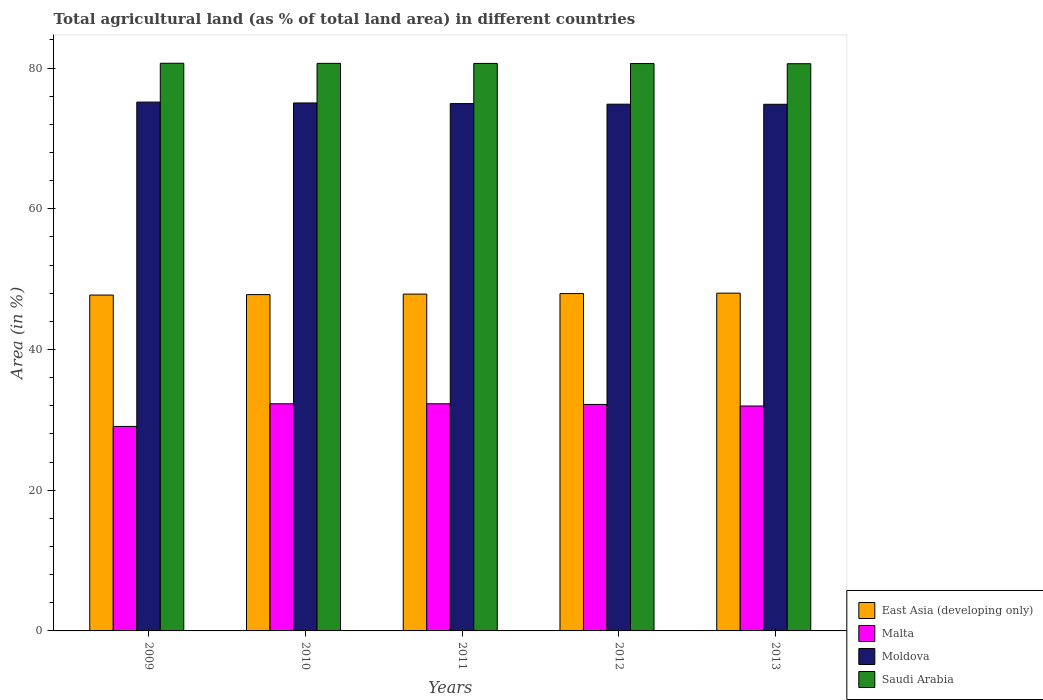How many groups of bars are there?
Provide a succinct answer. 5. What is the label of the 5th group of bars from the left?
Ensure brevity in your answer.  2013. What is the percentage of agricultural land in Malta in 2009?
Give a very brief answer. 29.06. Across all years, what is the maximum percentage of agricultural land in Malta?
Make the answer very short. 32.28. Across all years, what is the minimum percentage of agricultural land in Saudi Arabia?
Give a very brief answer. 80.61. What is the total percentage of agricultural land in Malta in the graph?
Provide a succinct answer. 157.78. What is the difference between the percentage of agricultural land in East Asia (developing only) in 2011 and that in 2013?
Give a very brief answer. -0.13. What is the difference between the percentage of agricultural land in East Asia (developing only) in 2010 and the percentage of agricultural land in Malta in 2013?
Your answer should be compact. 15.83. What is the average percentage of agricultural land in Malta per year?
Your response must be concise. 31.56. In the year 2013, what is the difference between the percentage of agricultural land in Saudi Arabia and percentage of agricultural land in Moldova?
Keep it short and to the point. 5.77. What is the ratio of the percentage of agricultural land in Saudi Arabia in 2009 to that in 2010?
Your response must be concise. 1. Is the percentage of agricultural land in Moldova in 2010 less than that in 2011?
Provide a succinct answer. No. Is the difference between the percentage of agricultural land in Saudi Arabia in 2010 and 2012 greater than the difference between the percentage of agricultural land in Moldova in 2010 and 2012?
Your response must be concise. No. What is the difference between the highest and the second highest percentage of agricultural land in Saudi Arabia?
Make the answer very short. 0.01. What is the difference between the highest and the lowest percentage of agricultural land in Saudi Arabia?
Offer a terse response. 0.07. Is the sum of the percentage of agricultural land in Malta in 2010 and 2012 greater than the maximum percentage of agricultural land in East Asia (developing only) across all years?
Provide a succinct answer. Yes. What does the 3rd bar from the left in 2009 represents?
Your answer should be very brief. Moldova. What does the 1st bar from the right in 2011 represents?
Offer a terse response. Saudi Arabia. Are all the bars in the graph horizontal?
Your response must be concise. No. How many years are there in the graph?
Give a very brief answer. 5. What is the difference between two consecutive major ticks on the Y-axis?
Ensure brevity in your answer.  20. Are the values on the major ticks of Y-axis written in scientific E-notation?
Your response must be concise. No. How many legend labels are there?
Keep it short and to the point. 4. How are the legend labels stacked?
Provide a short and direct response. Vertical. What is the title of the graph?
Your answer should be compact. Total agricultural land (as % of total land area) in different countries. What is the label or title of the Y-axis?
Keep it short and to the point. Area (in %). What is the Area (in %) of East Asia (developing only) in 2009?
Offer a terse response. 47.74. What is the Area (in %) in Malta in 2009?
Offer a very short reply. 29.06. What is the Area (in %) of Moldova in 2009?
Your answer should be very brief. 75.16. What is the Area (in %) of Saudi Arabia in 2009?
Give a very brief answer. 80.68. What is the Area (in %) of East Asia (developing only) in 2010?
Your response must be concise. 47.8. What is the Area (in %) in Malta in 2010?
Ensure brevity in your answer.  32.28. What is the Area (in %) of Moldova in 2010?
Make the answer very short. 75.04. What is the Area (in %) of Saudi Arabia in 2010?
Give a very brief answer. 80.67. What is the Area (in %) of East Asia (developing only) in 2011?
Your response must be concise. 47.87. What is the Area (in %) in Malta in 2011?
Provide a succinct answer. 32.28. What is the Area (in %) in Moldova in 2011?
Ensure brevity in your answer.  74.95. What is the Area (in %) in Saudi Arabia in 2011?
Offer a terse response. 80.66. What is the Area (in %) in East Asia (developing only) in 2012?
Ensure brevity in your answer.  47.95. What is the Area (in %) in Malta in 2012?
Give a very brief answer. 32.19. What is the Area (in %) in Moldova in 2012?
Ensure brevity in your answer.  74.86. What is the Area (in %) of Saudi Arabia in 2012?
Give a very brief answer. 80.64. What is the Area (in %) in East Asia (developing only) in 2013?
Ensure brevity in your answer.  48. What is the Area (in %) in Malta in 2013?
Offer a terse response. 31.97. What is the Area (in %) of Moldova in 2013?
Offer a very short reply. 74.85. What is the Area (in %) of Saudi Arabia in 2013?
Your answer should be compact. 80.61. Across all years, what is the maximum Area (in %) of East Asia (developing only)?
Your answer should be very brief. 48. Across all years, what is the maximum Area (in %) in Malta?
Your answer should be compact. 32.28. Across all years, what is the maximum Area (in %) of Moldova?
Offer a terse response. 75.16. Across all years, what is the maximum Area (in %) of Saudi Arabia?
Offer a very short reply. 80.68. Across all years, what is the minimum Area (in %) of East Asia (developing only)?
Ensure brevity in your answer.  47.74. Across all years, what is the minimum Area (in %) of Malta?
Your response must be concise. 29.06. Across all years, what is the minimum Area (in %) in Moldova?
Make the answer very short. 74.85. Across all years, what is the minimum Area (in %) of Saudi Arabia?
Provide a short and direct response. 80.61. What is the total Area (in %) in East Asia (developing only) in the graph?
Your answer should be compact. 239.35. What is the total Area (in %) of Malta in the graph?
Give a very brief answer. 157.78. What is the total Area (in %) of Moldova in the graph?
Give a very brief answer. 374.86. What is the total Area (in %) of Saudi Arabia in the graph?
Ensure brevity in your answer.  403.25. What is the difference between the Area (in %) in East Asia (developing only) in 2009 and that in 2010?
Offer a very short reply. -0.06. What is the difference between the Area (in %) of Malta in 2009 and that in 2010?
Give a very brief answer. -3.22. What is the difference between the Area (in %) in Moldova in 2009 and that in 2010?
Provide a succinct answer. 0.12. What is the difference between the Area (in %) in Saudi Arabia in 2009 and that in 2010?
Your answer should be compact. 0.01. What is the difference between the Area (in %) in East Asia (developing only) in 2009 and that in 2011?
Your answer should be compact. -0.14. What is the difference between the Area (in %) in Malta in 2009 and that in 2011?
Keep it short and to the point. -3.22. What is the difference between the Area (in %) of Moldova in 2009 and that in 2011?
Your answer should be compact. 0.21. What is the difference between the Area (in %) of Saudi Arabia in 2009 and that in 2011?
Your answer should be compact. 0.02. What is the difference between the Area (in %) in East Asia (developing only) in 2009 and that in 2012?
Offer a very short reply. -0.21. What is the difference between the Area (in %) of Malta in 2009 and that in 2012?
Your answer should be compact. -3.12. What is the difference between the Area (in %) of Moldova in 2009 and that in 2012?
Keep it short and to the point. 0.3. What is the difference between the Area (in %) in Saudi Arabia in 2009 and that in 2012?
Your answer should be very brief. 0.04. What is the difference between the Area (in %) in East Asia (developing only) in 2009 and that in 2013?
Your answer should be compact. -0.27. What is the difference between the Area (in %) in Malta in 2009 and that in 2013?
Your answer should be very brief. -2.91. What is the difference between the Area (in %) of Moldova in 2009 and that in 2013?
Your answer should be compact. 0.31. What is the difference between the Area (in %) in Saudi Arabia in 2009 and that in 2013?
Provide a succinct answer. 0.07. What is the difference between the Area (in %) in East Asia (developing only) in 2010 and that in 2011?
Ensure brevity in your answer.  -0.08. What is the difference between the Area (in %) of Malta in 2010 and that in 2011?
Offer a very short reply. 0. What is the difference between the Area (in %) of Moldova in 2010 and that in 2011?
Your answer should be compact. 0.09. What is the difference between the Area (in %) in Saudi Arabia in 2010 and that in 2011?
Make the answer very short. 0.01. What is the difference between the Area (in %) of East Asia (developing only) in 2010 and that in 2012?
Provide a succinct answer. -0.15. What is the difference between the Area (in %) in Malta in 2010 and that in 2012?
Your response must be concise. 0.09. What is the difference between the Area (in %) in Moldova in 2010 and that in 2012?
Offer a very short reply. 0.17. What is the difference between the Area (in %) of Saudi Arabia in 2010 and that in 2012?
Give a very brief answer. 0.03. What is the difference between the Area (in %) in East Asia (developing only) in 2010 and that in 2013?
Your response must be concise. -0.21. What is the difference between the Area (in %) of Malta in 2010 and that in 2013?
Your response must be concise. 0.31. What is the difference between the Area (in %) of Moldova in 2010 and that in 2013?
Offer a very short reply. 0.19. What is the difference between the Area (in %) of Saudi Arabia in 2010 and that in 2013?
Offer a very short reply. 0.05. What is the difference between the Area (in %) in East Asia (developing only) in 2011 and that in 2012?
Make the answer very short. -0.07. What is the difference between the Area (in %) in Malta in 2011 and that in 2012?
Your answer should be very brief. 0.09. What is the difference between the Area (in %) in Moldova in 2011 and that in 2012?
Provide a succinct answer. 0.08. What is the difference between the Area (in %) in Saudi Arabia in 2011 and that in 2012?
Provide a short and direct response. 0.02. What is the difference between the Area (in %) in East Asia (developing only) in 2011 and that in 2013?
Provide a succinct answer. -0.13. What is the difference between the Area (in %) of Malta in 2011 and that in 2013?
Your response must be concise. 0.31. What is the difference between the Area (in %) in Moldova in 2011 and that in 2013?
Give a very brief answer. 0.1. What is the difference between the Area (in %) in Saudi Arabia in 2011 and that in 2013?
Ensure brevity in your answer.  0.04. What is the difference between the Area (in %) of East Asia (developing only) in 2012 and that in 2013?
Give a very brief answer. -0.06. What is the difference between the Area (in %) of Malta in 2012 and that in 2013?
Keep it short and to the point. 0.22. What is the difference between the Area (in %) of Moldova in 2012 and that in 2013?
Offer a terse response. 0.02. What is the difference between the Area (in %) of Saudi Arabia in 2012 and that in 2013?
Provide a succinct answer. 0.02. What is the difference between the Area (in %) of East Asia (developing only) in 2009 and the Area (in %) of Malta in 2010?
Keep it short and to the point. 15.45. What is the difference between the Area (in %) in East Asia (developing only) in 2009 and the Area (in %) in Moldova in 2010?
Your answer should be compact. -27.3. What is the difference between the Area (in %) in East Asia (developing only) in 2009 and the Area (in %) in Saudi Arabia in 2010?
Keep it short and to the point. -32.93. What is the difference between the Area (in %) in Malta in 2009 and the Area (in %) in Moldova in 2010?
Ensure brevity in your answer.  -45.98. What is the difference between the Area (in %) in Malta in 2009 and the Area (in %) in Saudi Arabia in 2010?
Provide a short and direct response. -51.6. What is the difference between the Area (in %) of Moldova in 2009 and the Area (in %) of Saudi Arabia in 2010?
Ensure brevity in your answer.  -5.51. What is the difference between the Area (in %) in East Asia (developing only) in 2009 and the Area (in %) in Malta in 2011?
Provide a succinct answer. 15.45. What is the difference between the Area (in %) in East Asia (developing only) in 2009 and the Area (in %) in Moldova in 2011?
Provide a short and direct response. -27.21. What is the difference between the Area (in %) in East Asia (developing only) in 2009 and the Area (in %) in Saudi Arabia in 2011?
Give a very brief answer. -32.92. What is the difference between the Area (in %) of Malta in 2009 and the Area (in %) of Moldova in 2011?
Offer a terse response. -45.88. What is the difference between the Area (in %) of Malta in 2009 and the Area (in %) of Saudi Arabia in 2011?
Provide a short and direct response. -51.59. What is the difference between the Area (in %) of Moldova in 2009 and the Area (in %) of Saudi Arabia in 2011?
Keep it short and to the point. -5.5. What is the difference between the Area (in %) of East Asia (developing only) in 2009 and the Area (in %) of Malta in 2012?
Provide a succinct answer. 15.55. What is the difference between the Area (in %) of East Asia (developing only) in 2009 and the Area (in %) of Moldova in 2012?
Your answer should be very brief. -27.13. What is the difference between the Area (in %) of East Asia (developing only) in 2009 and the Area (in %) of Saudi Arabia in 2012?
Ensure brevity in your answer.  -32.9. What is the difference between the Area (in %) in Malta in 2009 and the Area (in %) in Moldova in 2012?
Make the answer very short. -45.8. What is the difference between the Area (in %) in Malta in 2009 and the Area (in %) in Saudi Arabia in 2012?
Offer a terse response. -51.57. What is the difference between the Area (in %) of Moldova in 2009 and the Area (in %) of Saudi Arabia in 2012?
Keep it short and to the point. -5.48. What is the difference between the Area (in %) in East Asia (developing only) in 2009 and the Area (in %) in Malta in 2013?
Give a very brief answer. 15.77. What is the difference between the Area (in %) in East Asia (developing only) in 2009 and the Area (in %) in Moldova in 2013?
Offer a terse response. -27.11. What is the difference between the Area (in %) of East Asia (developing only) in 2009 and the Area (in %) of Saudi Arabia in 2013?
Provide a succinct answer. -32.88. What is the difference between the Area (in %) in Malta in 2009 and the Area (in %) in Moldova in 2013?
Your answer should be very brief. -45.79. What is the difference between the Area (in %) of Malta in 2009 and the Area (in %) of Saudi Arabia in 2013?
Provide a short and direct response. -51.55. What is the difference between the Area (in %) in Moldova in 2009 and the Area (in %) in Saudi Arabia in 2013?
Your answer should be very brief. -5.45. What is the difference between the Area (in %) in East Asia (developing only) in 2010 and the Area (in %) in Malta in 2011?
Give a very brief answer. 15.52. What is the difference between the Area (in %) in East Asia (developing only) in 2010 and the Area (in %) in Moldova in 2011?
Make the answer very short. -27.15. What is the difference between the Area (in %) in East Asia (developing only) in 2010 and the Area (in %) in Saudi Arabia in 2011?
Offer a very short reply. -32.86. What is the difference between the Area (in %) of Malta in 2010 and the Area (in %) of Moldova in 2011?
Provide a succinct answer. -42.67. What is the difference between the Area (in %) in Malta in 2010 and the Area (in %) in Saudi Arabia in 2011?
Make the answer very short. -48.38. What is the difference between the Area (in %) of Moldova in 2010 and the Area (in %) of Saudi Arabia in 2011?
Offer a terse response. -5.62. What is the difference between the Area (in %) in East Asia (developing only) in 2010 and the Area (in %) in Malta in 2012?
Make the answer very short. 15.61. What is the difference between the Area (in %) of East Asia (developing only) in 2010 and the Area (in %) of Moldova in 2012?
Your answer should be compact. -27.07. What is the difference between the Area (in %) of East Asia (developing only) in 2010 and the Area (in %) of Saudi Arabia in 2012?
Your response must be concise. -32.84. What is the difference between the Area (in %) of Malta in 2010 and the Area (in %) of Moldova in 2012?
Make the answer very short. -42.58. What is the difference between the Area (in %) in Malta in 2010 and the Area (in %) in Saudi Arabia in 2012?
Keep it short and to the point. -48.36. What is the difference between the Area (in %) of Moldova in 2010 and the Area (in %) of Saudi Arabia in 2012?
Give a very brief answer. -5.6. What is the difference between the Area (in %) in East Asia (developing only) in 2010 and the Area (in %) in Malta in 2013?
Your answer should be very brief. 15.83. What is the difference between the Area (in %) of East Asia (developing only) in 2010 and the Area (in %) of Moldova in 2013?
Your answer should be compact. -27.05. What is the difference between the Area (in %) in East Asia (developing only) in 2010 and the Area (in %) in Saudi Arabia in 2013?
Give a very brief answer. -32.82. What is the difference between the Area (in %) in Malta in 2010 and the Area (in %) in Moldova in 2013?
Provide a succinct answer. -42.57. What is the difference between the Area (in %) in Malta in 2010 and the Area (in %) in Saudi Arabia in 2013?
Offer a very short reply. -48.33. What is the difference between the Area (in %) in Moldova in 2010 and the Area (in %) in Saudi Arabia in 2013?
Keep it short and to the point. -5.58. What is the difference between the Area (in %) in East Asia (developing only) in 2011 and the Area (in %) in Malta in 2012?
Offer a terse response. 15.68. What is the difference between the Area (in %) in East Asia (developing only) in 2011 and the Area (in %) in Moldova in 2012?
Ensure brevity in your answer.  -26.99. What is the difference between the Area (in %) of East Asia (developing only) in 2011 and the Area (in %) of Saudi Arabia in 2012?
Give a very brief answer. -32.77. What is the difference between the Area (in %) of Malta in 2011 and the Area (in %) of Moldova in 2012?
Provide a short and direct response. -42.58. What is the difference between the Area (in %) of Malta in 2011 and the Area (in %) of Saudi Arabia in 2012?
Ensure brevity in your answer.  -48.36. What is the difference between the Area (in %) of Moldova in 2011 and the Area (in %) of Saudi Arabia in 2012?
Give a very brief answer. -5.69. What is the difference between the Area (in %) of East Asia (developing only) in 2011 and the Area (in %) of Malta in 2013?
Your response must be concise. 15.9. What is the difference between the Area (in %) in East Asia (developing only) in 2011 and the Area (in %) in Moldova in 2013?
Your response must be concise. -26.98. What is the difference between the Area (in %) of East Asia (developing only) in 2011 and the Area (in %) of Saudi Arabia in 2013?
Make the answer very short. -32.74. What is the difference between the Area (in %) of Malta in 2011 and the Area (in %) of Moldova in 2013?
Your answer should be compact. -42.57. What is the difference between the Area (in %) of Malta in 2011 and the Area (in %) of Saudi Arabia in 2013?
Provide a short and direct response. -48.33. What is the difference between the Area (in %) in Moldova in 2011 and the Area (in %) in Saudi Arabia in 2013?
Provide a succinct answer. -5.67. What is the difference between the Area (in %) in East Asia (developing only) in 2012 and the Area (in %) in Malta in 2013?
Your response must be concise. 15.98. What is the difference between the Area (in %) in East Asia (developing only) in 2012 and the Area (in %) in Moldova in 2013?
Your answer should be compact. -26.9. What is the difference between the Area (in %) in East Asia (developing only) in 2012 and the Area (in %) in Saudi Arabia in 2013?
Offer a terse response. -32.67. What is the difference between the Area (in %) in Malta in 2012 and the Area (in %) in Moldova in 2013?
Make the answer very short. -42.66. What is the difference between the Area (in %) in Malta in 2012 and the Area (in %) in Saudi Arabia in 2013?
Your answer should be compact. -48.43. What is the difference between the Area (in %) in Moldova in 2012 and the Area (in %) in Saudi Arabia in 2013?
Your answer should be very brief. -5.75. What is the average Area (in %) in East Asia (developing only) per year?
Offer a very short reply. 47.87. What is the average Area (in %) of Malta per year?
Provide a succinct answer. 31.56. What is the average Area (in %) of Moldova per year?
Your answer should be very brief. 74.97. What is the average Area (in %) of Saudi Arabia per year?
Your answer should be compact. 80.65. In the year 2009, what is the difference between the Area (in %) of East Asia (developing only) and Area (in %) of Malta?
Your answer should be very brief. 18.67. In the year 2009, what is the difference between the Area (in %) in East Asia (developing only) and Area (in %) in Moldova?
Give a very brief answer. -27.42. In the year 2009, what is the difference between the Area (in %) in East Asia (developing only) and Area (in %) in Saudi Arabia?
Keep it short and to the point. -32.94. In the year 2009, what is the difference between the Area (in %) in Malta and Area (in %) in Moldova?
Make the answer very short. -46.1. In the year 2009, what is the difference between the Area (in %) of Malta and Area (in %) of Saudi Arabia?
Provide a short and direct response. -51.62. In the year 2009, what is the difference between the Area (in %) in Moldova and Area (in %) in Saudi Arabia?
Keep it short and to the point. -5.52. In the year 2010, what is the difference between the Area (in %) of East Asia (developing only) and Area (in %) of Malta?
Your response must be concise. 15.52. In the year 2010, what is the difference between the Area (in %) of East Asia (developing only) and Area (in %) of Moldova?
Offer a very short reply. -27.24. In the year 2010, what is the difference between the Area (in %) of East Asia (developing only) and Area (in %) of Saudi Arabia?
Provide a succinct answer. -32.87. In the year 2010, what is the difference between the Area (in %) in Malta and Area (in %) in Moldova?
Provide a short and direct response. -42.76. In the year 2010, what is the difference between the Area (in %) of Malta and Area (in %) of Saudi Arabia?
Give a very brief answer. -48.38. In the year 2010, what is the difference between the Area (in %) of Moldova and Area (in %) of Saudi Arabia?
Provide a succinct answer. -5.63. In the year 2011, what is the difference between the Area (in %) of East Asia (developing only) and Area (in %) of Malta?
Your answer should be very brief. 15.59. In the year 2011, what is the difference between the Area (in %) in East Asia (developing only) and Area (in %) in Moldova?
Make the answer very short. -27.07. In the year 2011, what is the difference between the Area (in %) of East Asia (developing only) and Area (in %) of Saudi Arabia?
Offer a terse response. -32.79. In the year 2011, what is the difference between the Area (in %) in Malta and Area (in %) in Moldova?
Provide a short and direct response. -42.67. In the year 2011, what is the difference between the Area (in %) in Malta and Area (in %) in Saudi Arabia?
Offer a very short reply. -48.38. In the year 2011, what is the difference between the Area (in %) in Moldova and Area (in %) in Saudi Arabia?
Ensure brevity in your answer.  -5.71. In the year 2012, what is the difference between the Area (in %) in East Asia (developing only) and Area (in %) in Malta?
Your response must be concise. 15.76. In the year 2012, what is the difference between the Area (in %) in East Asia (developing only) and Area (in %) in Moldova?
Your response must be concise. -26.92. In the year 2012, what is the difference between the Area (in %) of East Asia (developing only) and Area (in %) of Saudi Arabia?
Give a very brief answer. -32.69. In the year 2012, what is the difference between the Area (in %) in Malta and Area (in %) in Moldova?
Your answer should be compact. -42.68. In the year 2012, what is the difference between the Area (in %) of Malta and Area (in %) of Saudi Arabia?
Offer a very short reply. -48.45. In the year 2012, what is the difference between the Area (in %) in Moldova and Area (in %) in Saudi Arabia?
Offer a very short reply. -5.77. In the year 2013, what is the difference between the Area (in %) of East Asia (developing only) and Area (in %) of Malta?
Your answer should be very brief. 16.03. In the year 2013, what is the difference between the Area (in %) in East Asia (developing only) and Area (in %) in Moldova?
Your response must be concise. -26.85. In the year 2013, what is the difference between the Area (in %) in East Asia (developing only) and Area (in %) in Saudi Arabia?
Keep it short and to the point. -32.61. In the year 2013, what is the difference between the Area (in %) of Malta and Area (in %) of Moldova?
Give a very brief answer. -42.88. In the year 2013, what is the difference between the Area (in %) in Malta and Area (in %) in Saudi Arabia?
Make the answer very short. -48.65. In the year 2013, what is the difference between the Area (in %) of Moldova and Area (in %) of Saudi Arabia?
Offer a terse response. -5.77. What is the ratio of the Area (in %) of East Asia (developing only) in 2009 to that in 2010?
Ensure brevity in your answer.  1. What is the ratio of the Area (in %) of Malta in 2009 to that in 2010?
Provide a short and direct response. 0.9. What is the ratio of the Area (in %) of Moldova in 2009 to that in 2010?
Your answer should be very brief. 1. What is the ratio of the Area (in %) of Malta in 2009 to that in 2011?
Offer a very short reply. 0.9. What is the ratio of the Area (in %) in East Asia (developing only) in 2009 to that in 2012?
Offer a terse response. 1. What is the ratio of the Area (in %) of Malta in 2009 to that in 2012?
Ensure brevity in your answer.  0.9. What is the ratio of the Area (in %) in Moldova in 2009 to that in 2013?
Your answer should be compact. 1. What is the ratio of the Area (in %) of Saudi Arabia in 2009 to that in 2013?
Offer a very short reply. 1. What is the ratio of the Area (in %) of East Asia (developing only) in 2010 to that in 2011?
Make the answer very short. 1. What is the ratio of the Area (in %) of Malta in 2010 to that in 2011?
Offer a very short reply. 1. What is the ratio of the Area (in %) of Moldova in 2010 to that in 2011?
Provide a succinct answer. 1. What is the ratio of the Area (in %) in Moldova in 2010 to that in 2012?
Your response must be concise. 1. What is the ratio of the Area (in %) in Saudi Arabia in 2010 to that in 2012?
Offer a terse response. 1. What is the ratio of the Area (in %) in Malta in 2010 to that in 2013?
Make the answer very short. 1.01. What is the ratio of the Area (in %) in Moldova in 2010 to that in 2013?
Provide a short and direct response. 1. What is the ratio of the Area (in %) of Saudi Arabia in 2010 to that in 2013?
Offer a terse response. 1. What is the ratio of the Area (in %) in East Asia (developing only) in 2011 to that in 2012?
Ensure brevity in your answer.  1. What is the ratio of the Area (in %) in Malta in 2011 to that in 2012?
Your answer should be very brief. 1. What is the ratio of the Area (in %) of Moldova in 2011 to that in 2012?
Give a very brief answer. 1. What is the ratio of the Area (in %) in Saudi Arabia in 2011 to that in 2012?
Ensure brevity in your answer.  1. What is the ratio of the Area (in %) of Malta in 2011 to that in 2013?
Offer a terse response. 1.01. What is the ratio of the Area (in %) of Moldova in 2011 to that in 2013?
Provide a short and direct response. 1. What is the ratio of the Area (in %) of Saudi Arabia in 2011 to that in 2013?
Keep it short and to the point. 1. What is the ratio of the Area (in %) in Malta in 2012 to that in 2013?
Offer a very short reply. 1.01. What is the ratio of the Area (in %) in Moldova in 2012 to that in 2013?
Your response must be concise. 1. What is the difference between the highest and the second highest Area (in %) in East Asia (developing only)?
Offer a terse response. 0.06. What is the difference between the highest and the second highest Area (in %) of Moldova?
Ensure brevity in your answer.  0.12. What is the difference between the highest and the second highest Area (in %) in Saudi Arabia?
Your answer should be very brief. 0.01. What is the difference between the highest and the lowest Area (in %) in East Asia (developing only)?
Your answer should be compact. 0.27. What is the difference between the highest and the lowest Area (in %) in Malta?
Provide a succinct answer. 3.22. What is the difference between the highest and the lowest Area (in %) of Moldova?
Offer a very short reply. 0.31. What is the difference between the highest and the lowest Area (in %) in Saudi Arabia?
Give a very brief answer. 0.07. 